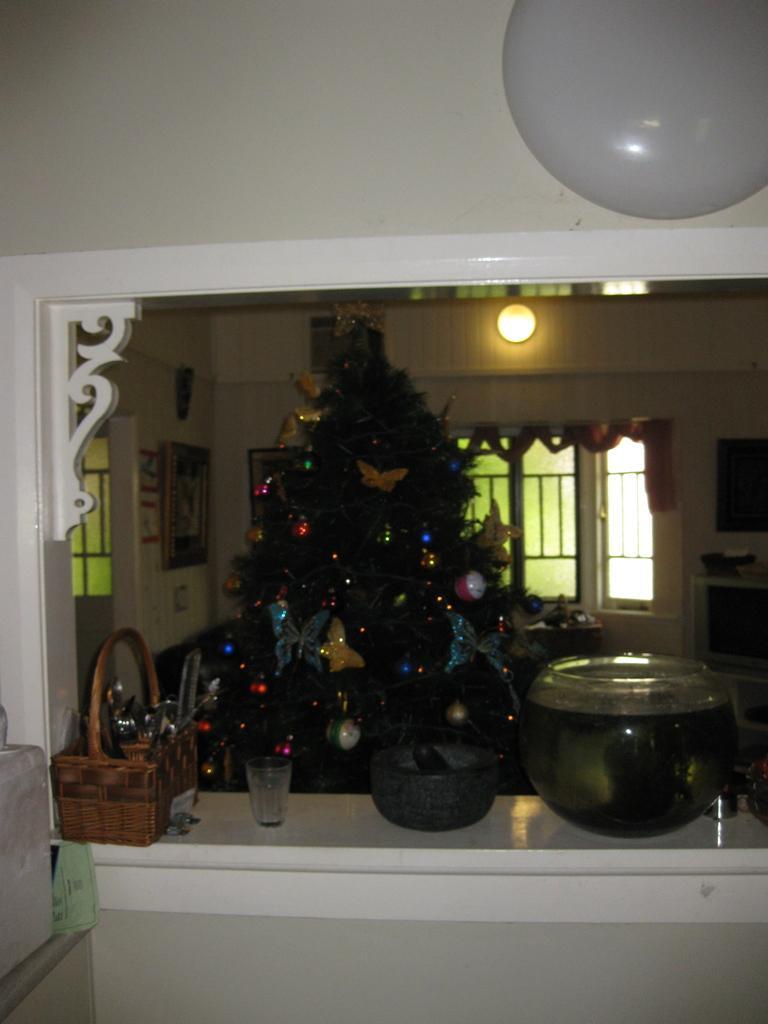Please provide a concise description of this image. In the image we can see the Christmas tree and decorative items. Here we can see container, glass and wooden basket. Here we can see light, window and the wall. 